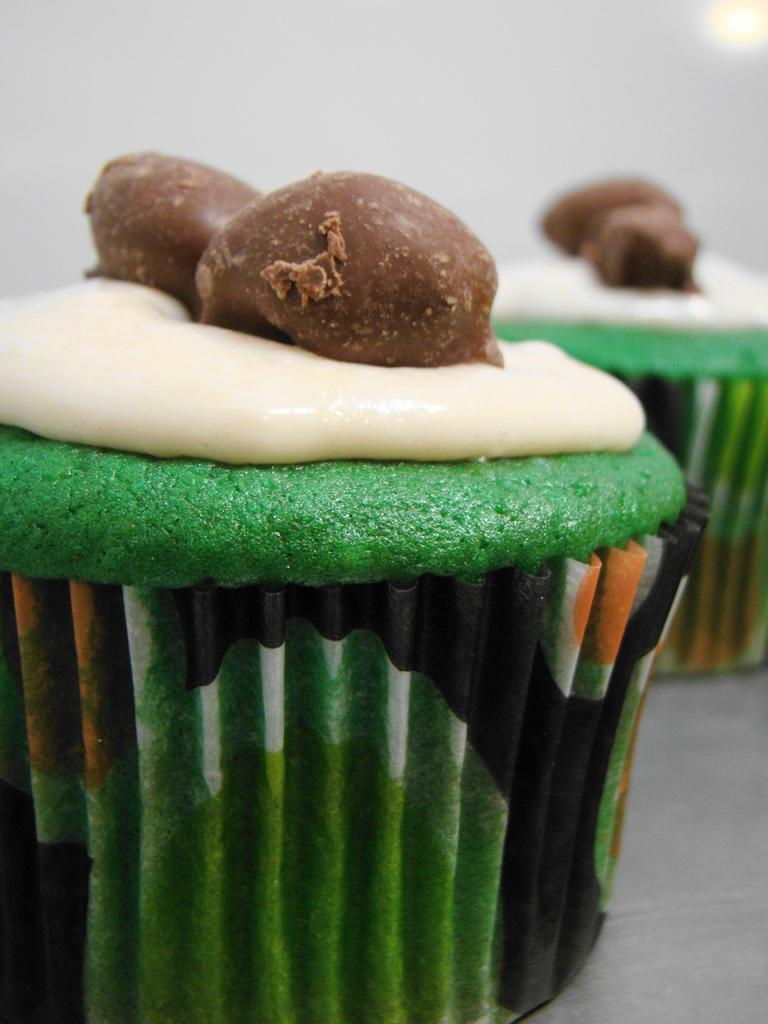What type of food can be seen in the image? There are cupcakes in the image. What arithmetic problem can be solved using the cupcakes in the image? There is no arithmetic problem present in the image, as it only features cupcakes. What type of cheese is used to make the cupcakes in the image? There is no cheese mentioned or visible in the image, as it only features cupcakes. 